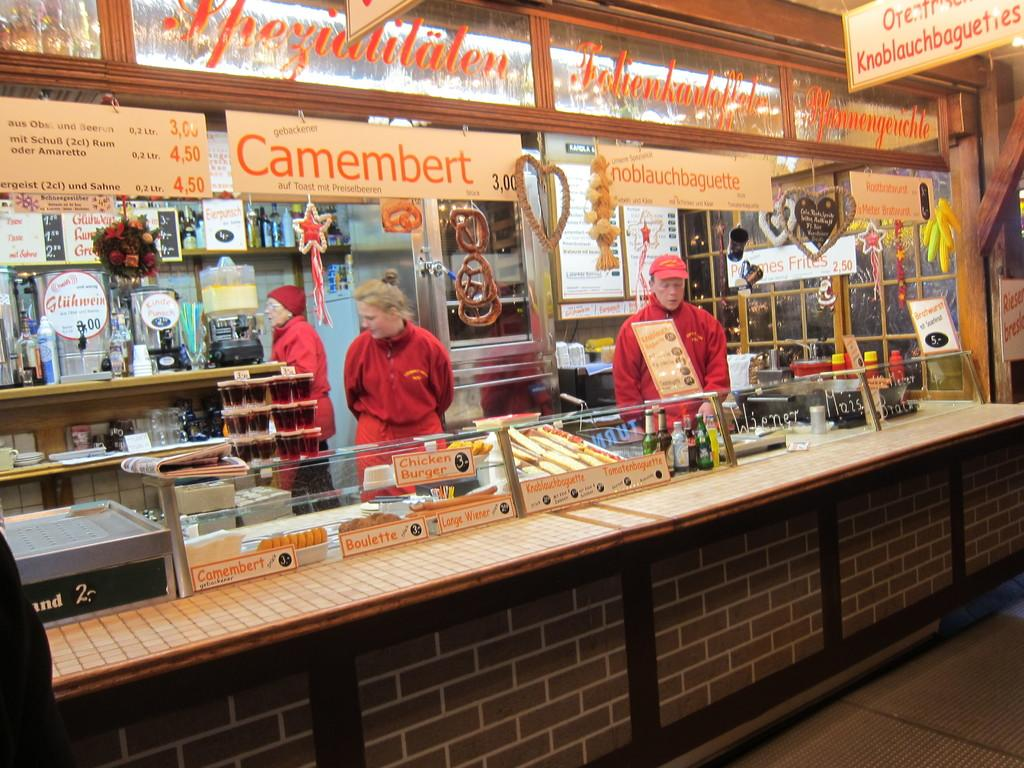<image>
Share a concise interpretation of the image provided. A store advertising Camember and noblauchbaguette has 3 workers on duty. 